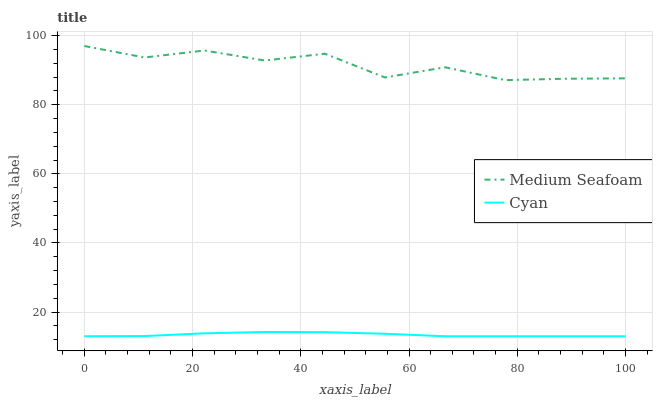Does Cyan have the minimum area under the curve?
Answer yes or no. Yes. Does Medium Seafoam have the maximum area under the curve?
Answer yes or no. Yes. Does Medium Seafoam have the minimum area under the curve?
Answer yes or no. No. Is Cyan the smoothest?
Answer yes or no. Yes. Is Medium Seafoam the roughest?
Answer yes or no. Yes. Is Medium Seafoam the smoothest?
Answer yes or no. No. Does Cyan have the lowest value?
Answer yes or no. Yes. Does Medium Seafoam have the lowest value?
Answer yes or no. No. Does Medium Seafoam have the highest value?
Answer yes or no. Yes. Is Cyan less than Medium Seafoam?
Answer yes or no. Yes. Is Medium Seafoam greater than Cyan?
Answer yes or no. Yes. Does Cyan intersect Medium Seafoam?
Answer yes or no. No. 